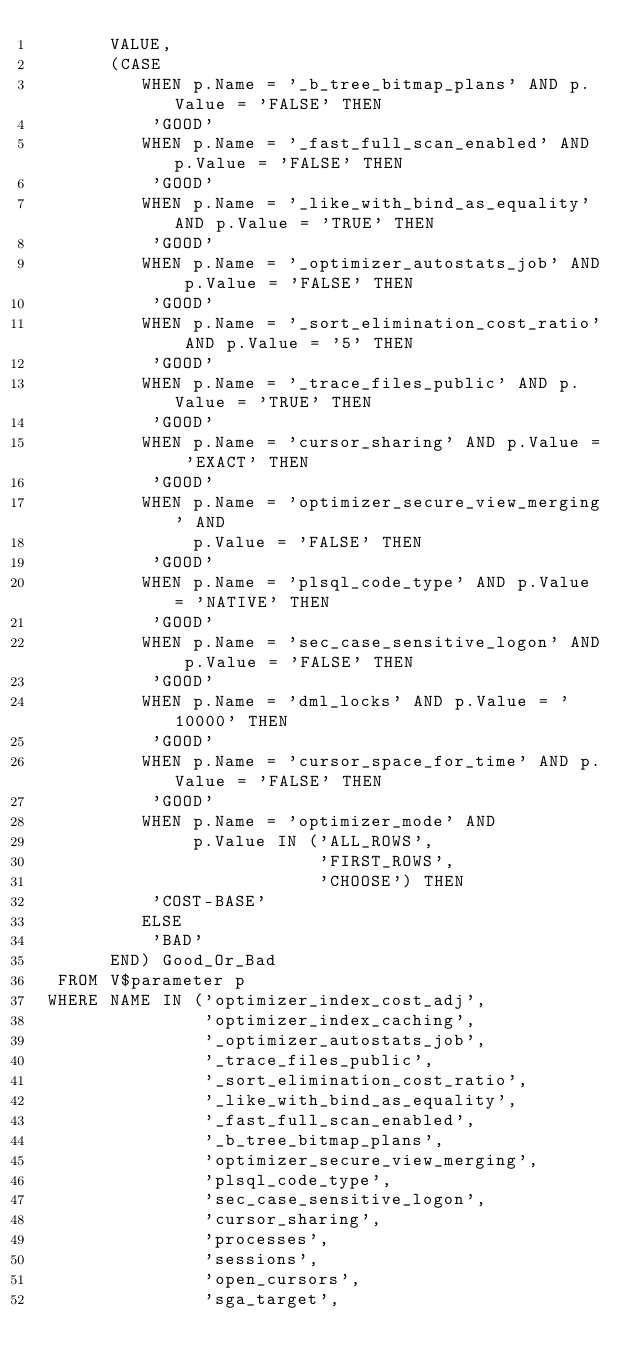Convert code to text. <code><loc_0><loc_0><loc_500><loc_500><_SQL_>       VALUE,
       (CASE
          WHEN p.Name = '_b_tree_bitmap_plans' AND p.Value = 'FALSE' THEN
           'GOOD'
          WHEN p.Name = '_fast_full_scan_enabled' AND p.Value = 'FALSE' THEN
           'GOOD'
          WHEN p.Name = '_like_with_bind_as_equality' AND p.Value = 'TRUE' THEN
           'GOOD'
          WHEN p.Name = '_optimizer_autostats_job' AND p.Value = 'FALSE' THEN
           'GOOD'
          WHEN p.Name = '_sort_elimination_cost_ratio' AND p.Value = '5' THEN
           'GOOD'
          WHEN p.Name = '_trace_files_public' AND p.Value = 'TRUE' THEN
           'GOOD'
          WHEN p.Name = 'cursor_sharing' AND p.Value = 'EXACT' THEN
           'GOOD'
          WHEN p.Name = 'optimizer_secure_view_merging' AND
               p.Value = 'FALSE' THEN
           'GOOD'
          WHEN p.Name = 'plsql_code_type' AND p.Value = 'NATIVE' THEN
           'GOOD'
          WHEN p.Name = 'sec_case_sensitive_logon' AND p.Value = 'FALSE' THEN
           'GOOD'
          WHEN p.Name = 'dml_locks' AND p.Value = '10000' THEN
           'GOOD'
          WHEN p.Name = 'cursor_space_for_time' AND p.Value = 'FALSE' THEN
           'GOOD'
          WHEN p.Name = 'optimizer_mode' AND
               p.Value IN ('ALL_ROWS',
                           'FIRST_ROWS',
                           'CHOOSE') THEN
           'COST-BASE'
          ELSE
           'BAD'
       END) Good_Or_Bad
  FROM V$parameter p
 WHERE NAME IN ('optimizer_index_cost_adj',
                'optimizer_index_caching',
                '_optimizer_autostats_job',
                '_trace_files_public',
                '_sort_elimination_cost_ratio',
                '_like_with_bind_as_equality',
                '_fast_full_scan_enabled',
                '_b_tree_bitmap_plans',
                'optimizer_secure_view_merging',
                'plsql_code_type',
                'sec_case_sensitive_logon',
                'cursor_sharing',
                'processes',
                'sessions',
                'open_cursors',
                'sga_target',</code> 